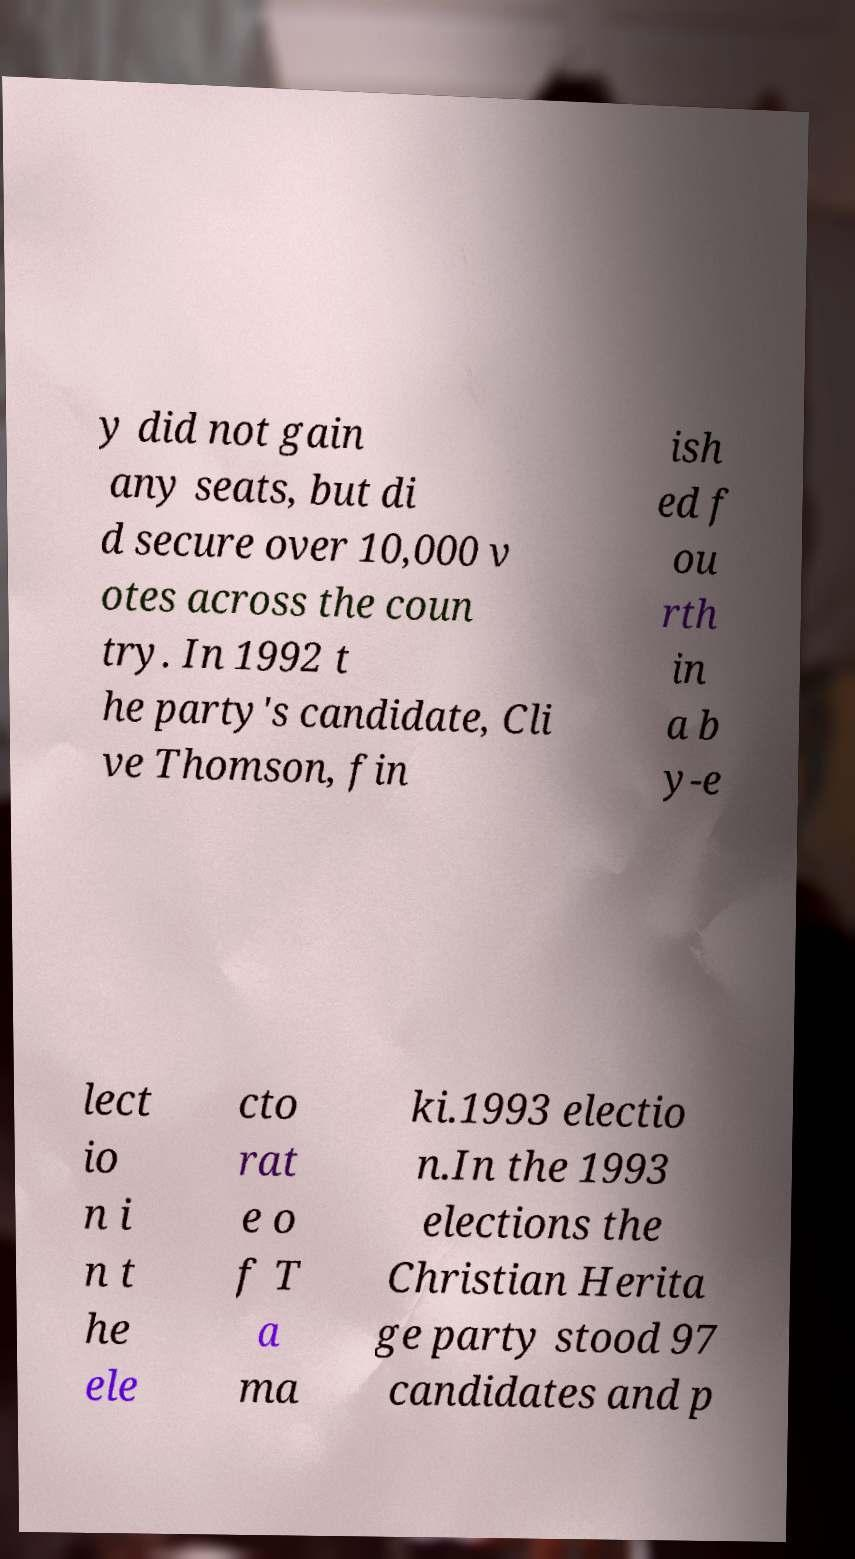Could you extract and type out the text from this image? y did not gain any seats, but di d secure over 10,000 v otes across the coun try. In 1992 t he party's candidate, Cli ve Thomson, fin ish ed f ou rth in a b y-e lect io n i n t he ele cto rat e o f T a ma ki.1993 electio n.In the 1993 elections the Christian Herita ge party stood 97 candidates and p 